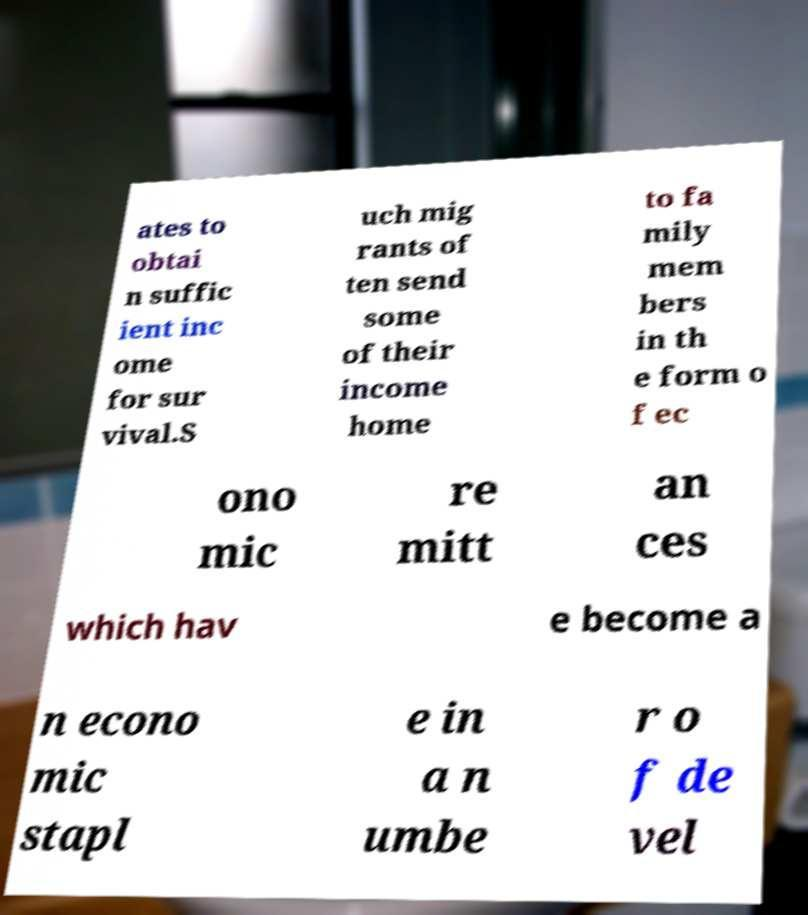Please read and relay the text visible in this image. What does it say? ates to obtai n suffic ient inc ome for sur vival.S uch mig rants of ten send some of their income home to fa mily mem bers in th e form o f ec ono mic re mitt an ces which hav e become a n econo mic stapl e in a n umbe r o f de vel 